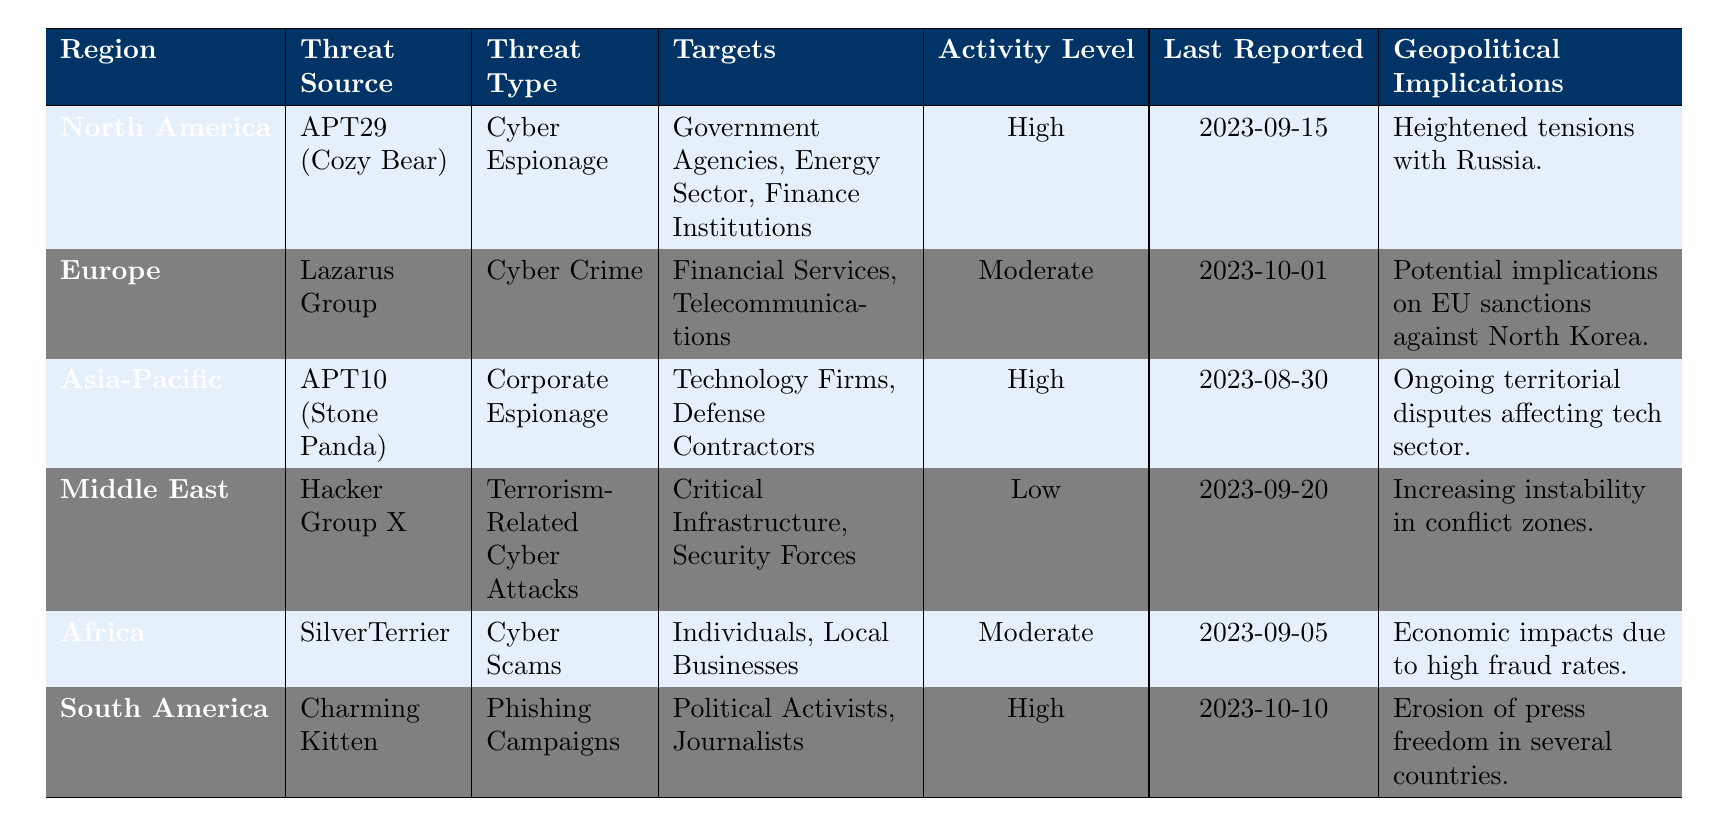What is the threat source for North America? The table contains the row for North America, where the threat source is explicitly listed as APT29 (Cozy Bear).
Answer: APT29 (Cozy Bear) Which region has the highest activity level? By scanning the activity levels in the table, North America, Asia-Pacific, and South America are all listed as high. North America has the earliest report date, but all three regions have the same activity level.
Answer: North America, Asia-Pacific, and South America What was the last reported date for threats in Europe? Looking at the entry for Europe, the last reported date is provided as 2023-10-01.
Answer: 2023-10-01 Is the activity level for threats in the Middle East high? In the table, the activity level for the Middle East is noted as low, which answers the question.
Answer: No What are the targets of the Lazarus Group? The row for Europe specifies that the Lazarus Group targets financial services and telecommunications.
Answer: Financial Services, Telecommunications Which region shows implications of instability in conflict zones? Referring to the Middle East's row, it directly states increasing instability in conflict zones as an implication.
Answer: Middle East How many regions have a threat type of "Cyber Espionage"? By reviewing each region in the table, both North America and Asia-Pacific are associated with "Cyber Espionage," so there are two such regions.
Answer: 2 What implication is associated with threats from APT10 (Stone Panda) in Asia-Pacific? The entry for Asia-Pacific indicates that ongoing territorial disputes are affecting the tech sector, providing the necessary geopolitical implication.
Answer: Ongoing territorial disputes affecting tech sector Which threat type has been reported for South America? The row for South America specifies that the threat type is "Phishing Campaigns."
Answer: Phishing Campaigns Which region has reported threats related to cyber scams? The Africa row describes the threats from SilverTerrier as cyber scams, answering the question directly.
Answer: Africa 